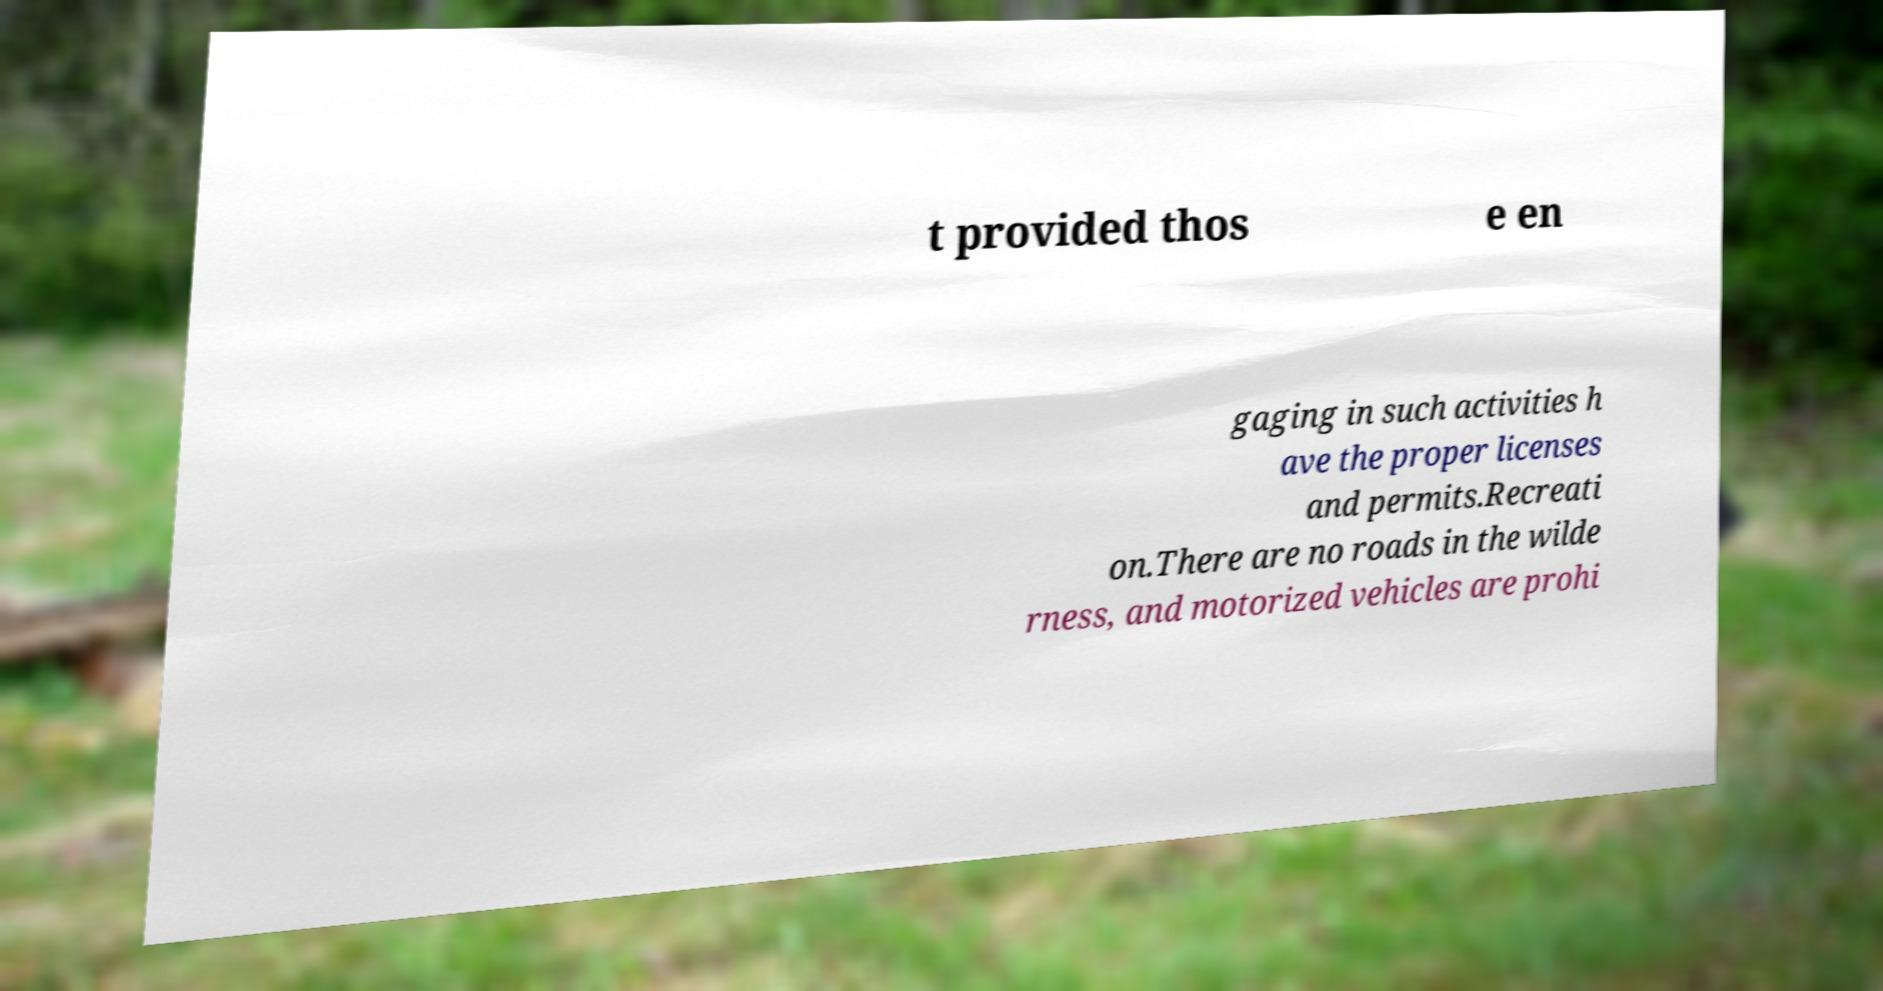I need the written content from this picture converted into text. Can you do that? t provided thos e en gaging in such activities h ave the proper licenses and permits.Recreati on.There are no roads in the wilde rness, and motorized vehicles are prohi 